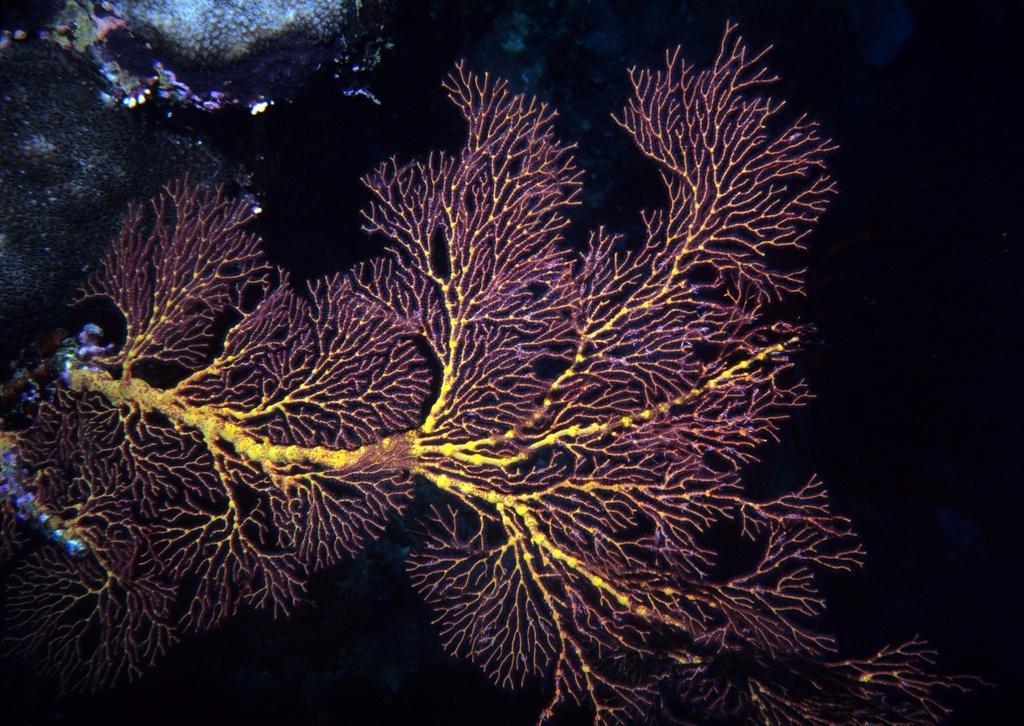Can you describe this image briefly? In this image we can see a plant and in the background on the left side there are objects and on the right side the image is dark. 